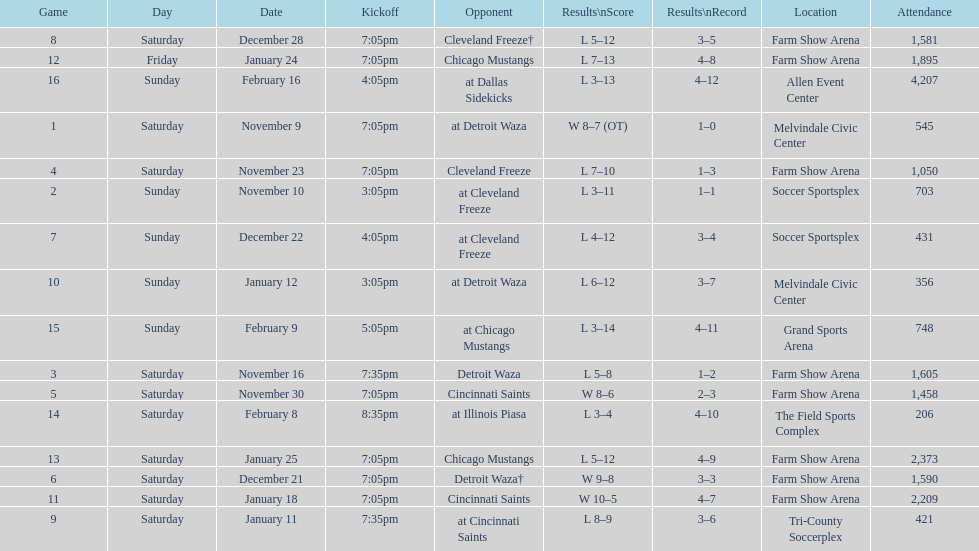What was the duration of the team's lengthiest losing streak? 5 games. 